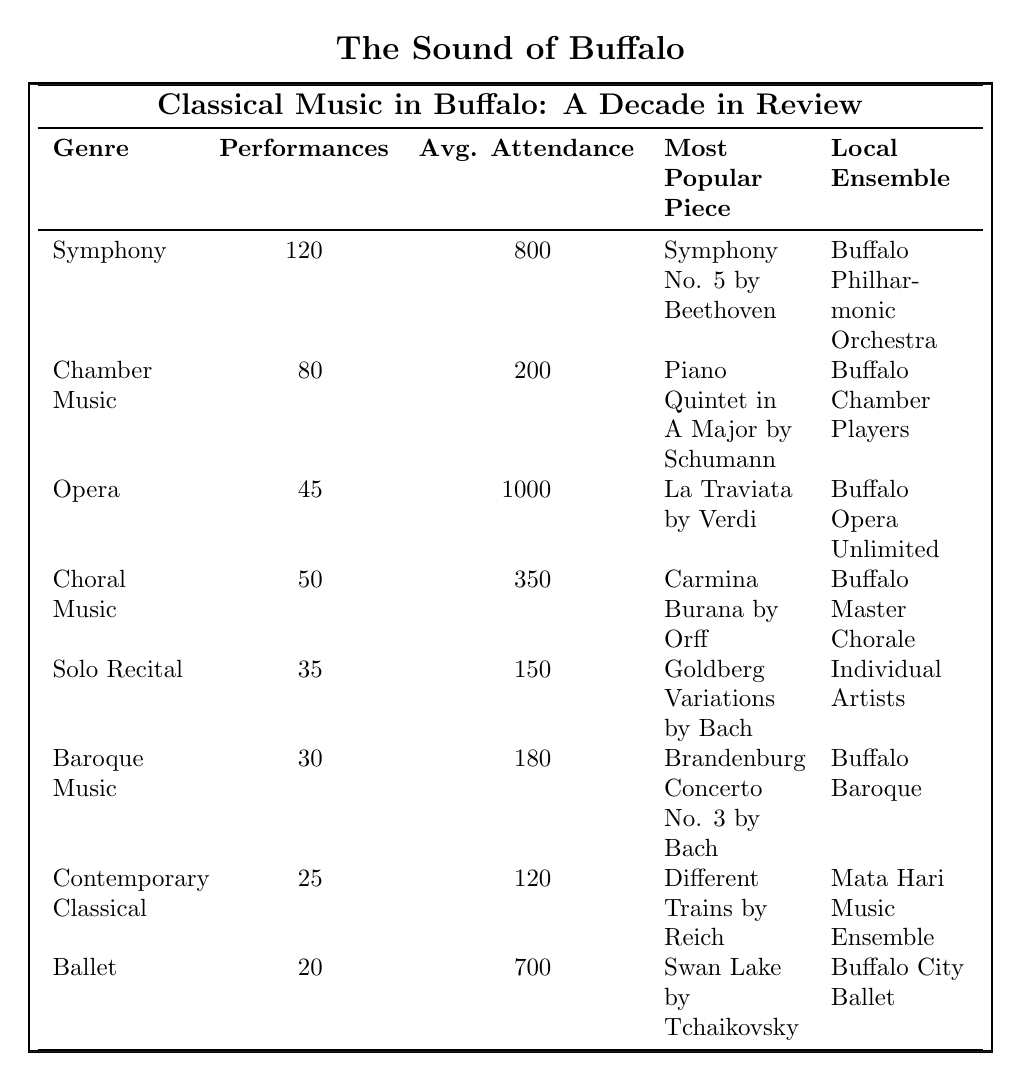What is the genre with the highest number of performances? According to the table, Symphony has the highest number of performances at 120.
Answer: Symphony Which genre has the highest average attendance? The table shows that Opera has the highest average attendance, with 1000 people attending on average.
Answer: Opera What is the most popular piece performed by the Buffalo Philharmonic Orchestra? The table indicates that the most popular piece performed by the Buffalo Philharmonic Orchestra is Symphony No. 5 by Beethoven.
Answer: Symphony No. 5 by Beethoven How many total performances were there across all genres? To find the total performances, add all the performances from the genres: 120 + 80 + 45 + 50 + 35 + 30 + 25 + 20 = 405.
Answer: 405 What is the average attendance for Chamber Music performances? The table states that the average attendance for Chamber Music is 200.
Answer: 200 Which genre had the least number of performances? The least number of performances is for Ballet, with 20 performances, as seen in the table.
Answer: Ballet Is the average attendance for Solo Recital higher than that for Contemporary Classical? The average attendance for Solo Recital is 150, while for Contemporary Classical, it is 120. Thus, yes, Solo Recital has a higher average attendance.
Answer: Yes What is the difference in average attendance between Symphony and Choral Music? Symphony has an average attendance of 800 and Choral Music has 350. The difference is 800 - 350 = 450.
Answer: 450 What is the total average attendance for all listed genres? To find the total average attendance, we sum the average attendances: 800 + 200 + 1000 + 350 + 150 + 180 + 120 + 700 = 2500.
Answer: 2500 Which two genres have a combined total of at least 200 performances? Symphony (120) and Chamber Music (80) together have 120 + 80 = 200 performances, which meets the requirement.
Answer: Symphony and Chamber Music 